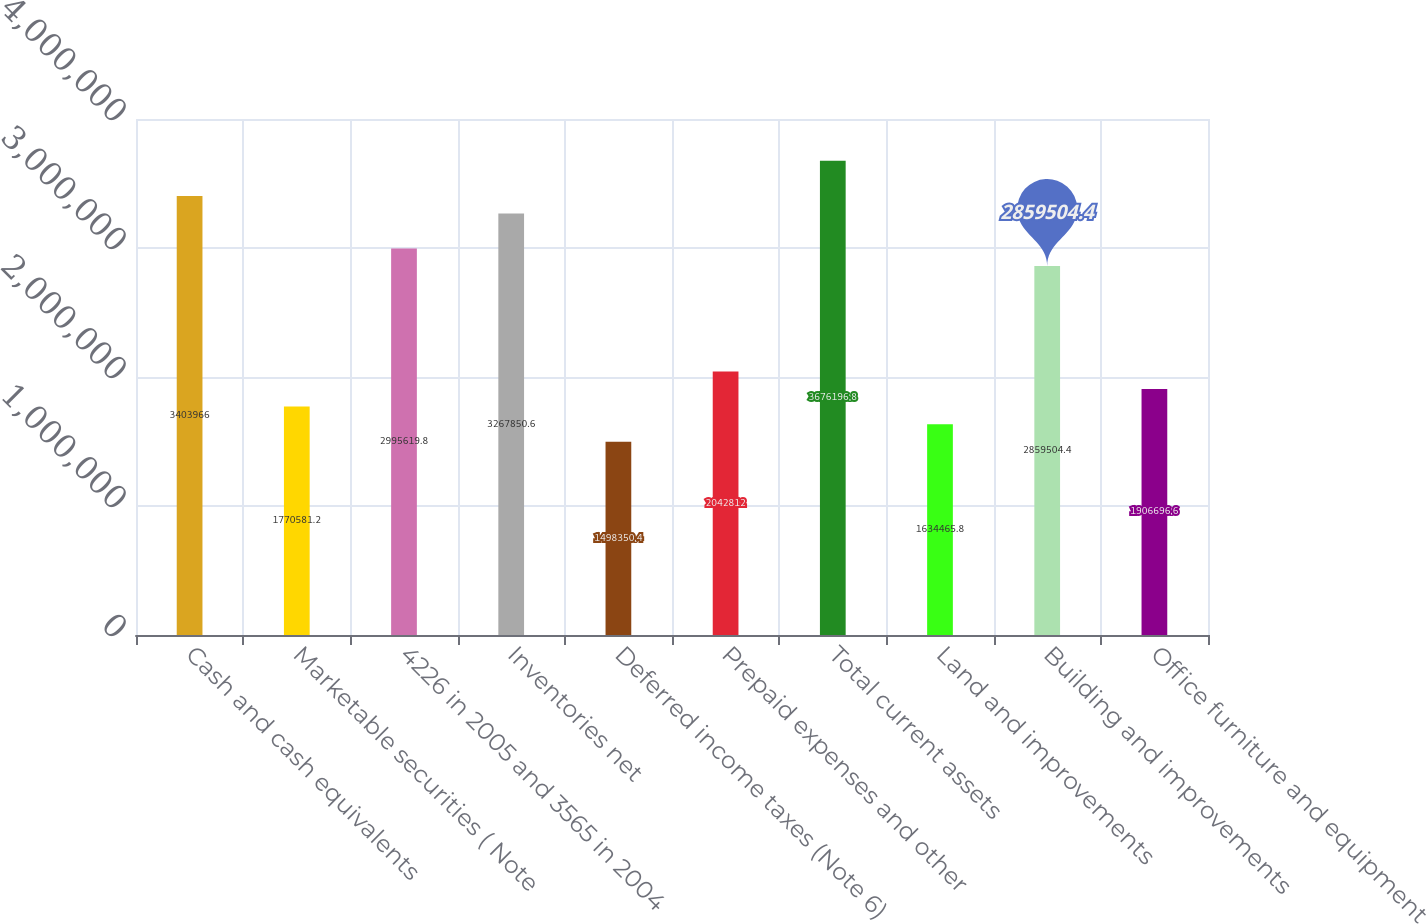Convert chart. <chart><loc_0><loc_0><loc_500><loc_500><bar_chart><fcel>Cash and cash equivalents<fcel>Marketable securities ( Note<fcel>4226 in 2005 and 3565 in 2004<fcel>Inventories net<fcel>Deferred income taxes (Note 6)<fcel>Prepaid expenses and other<fcel>Total current assets<fcel>Land and improvements<fcel>Building and improvements<fcel>Office furniture and equipment<nl><fcel>3.40397e+06<fcel>1.77058e+06<fcel>2.99562e+06<fcel>3.26785e+06<fcel>1.49835e+06<fcel>2.04281e+06<fcel>3.6762e+06<fcel>1.63447e+06<fcel>2.8595e+06<fcel>1.9067e+06<nl></chart> 